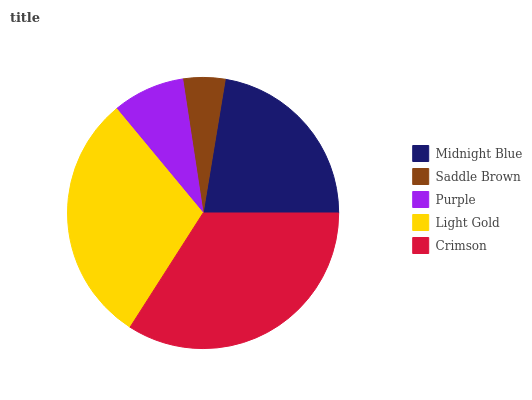Is Saddle Brown the minimum?
Answer yes or no. Yes. Is Crimson the maximum?
Answer yes or no. Yes. Is Purple the minimum?
Answer yes or no. No. Is Purple the maximum?
Answer yes or no. No. Is Purple greater than Saddle Brown?
Answer yes or no. Yes. Is Saddle Brown less than Purple?
Answer yes or no. Yes. Is Saddle Brown greater than Purple?
Answer yes or no. No. Is Purple less than Saddle Brown?
Answer yes or no. No. Is Midnight Blue the high median?
Answer yes or no. Yes. Is Midnight Blue the low median?
Answer yes or no. Yes. Is Light Gold the high median?
Answer yes or no. No. Is Light Gold the low median?
Answer yes or no. No. 